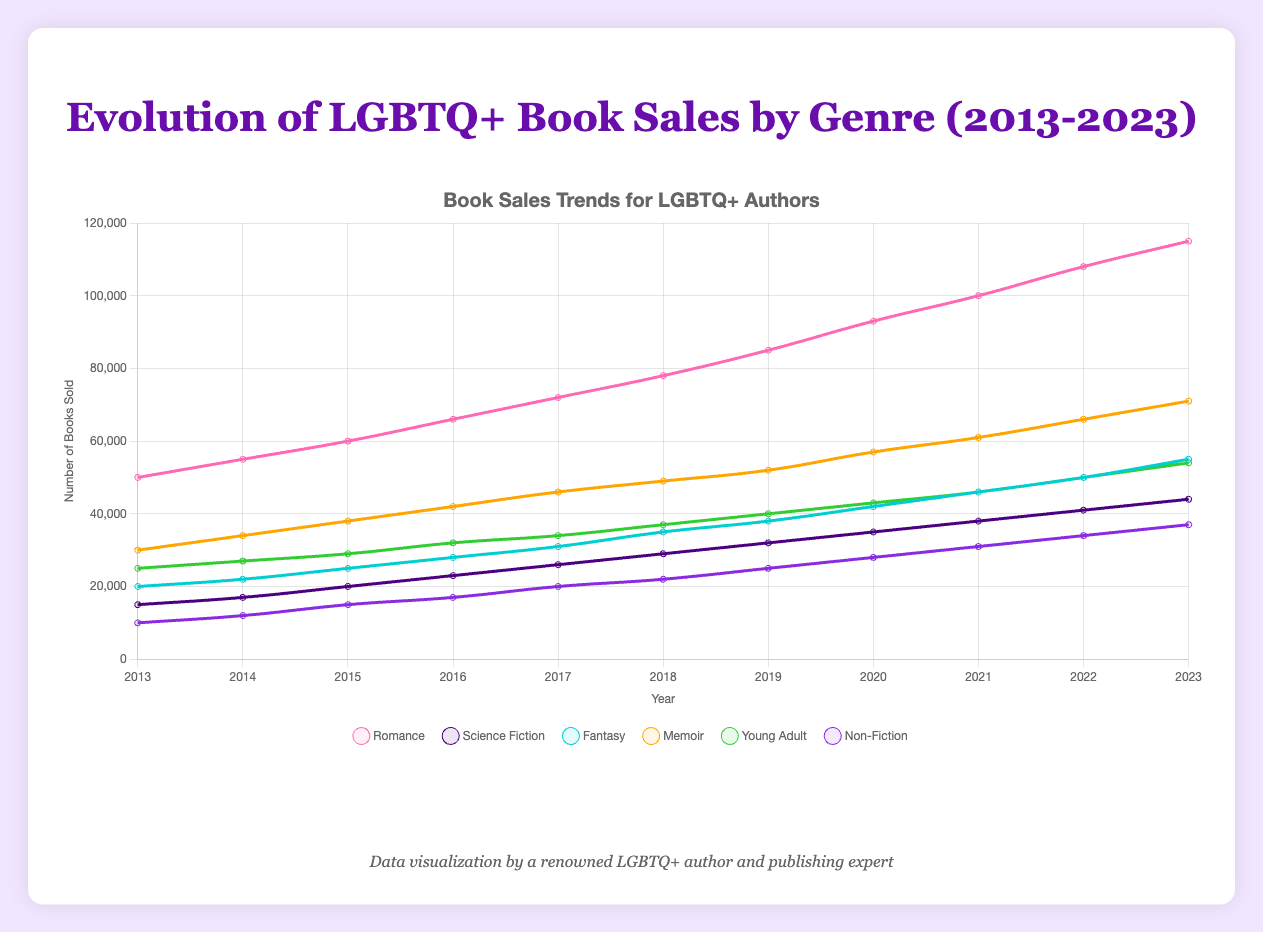How has the sales trend for Romance books changed over the last decade? Looking at the curve for Romance books, the sales have steadily increased from 50,000 in 2013 to 115,000 in 2023. The trend shows a consistent and significant upward movement.
Answer: Steady increase Which genre had the lowest sales in 2013, and how has it changed over time? In 2013, Non-Fiction had the lowest sales at 10,000. Over the decade, it has gradually increased each year, reaching 37,000 by 2023.
Answer: Non-Fiction, increased to 37,000 Which genre had the highest growth in book sales between 2013 and 2023? To determine the genre with the highest growth, compare the data points of each genre for 2013 and 2023. Romance had the highest increase, from 50,000 in 2013 to 115,000 in 2023, a growth of 65,000.
Answer: Romance Compare the sales of Fantasy and Young Adult books in 2023. Which one sold more, and by how much? Fantasy had 55,000 sales in 2023, while Young Adult had 54,000 sales. Fantasy sold 1,000 more books than Young Adult.
Answer: Fantasy, 1,000 more What is the average yearly sales increase for Memoir books from 2013 to 2023? Memoir sales in 2013 were 30,000, and in 2023 they were 71,000. The increase over 10 years is 71,000 - 30,000 = 41,000. The average yearly increase is 41,000 / 10 = 4,100 books per year.
Answer: 4,100 per year Between Science Fiction and Memoir, which genre had a more consistent growth, given the shape of the curves? The Memoir curve shows a steady and linear increase, while Science Fiction exhibits a more variable growth pattern. Therefore, Memoir had a more consistent growth.
Answer: Memoir How did the sales for Young Adult books change from 2017 to 2020? In 2017, Young Adult books had 34,000 sales, and in 2020 they had 43,000 sales. The increase over these three years is 43,000 - 34,000 = 9,000 books.
Answer: Increased by 9,000 What overall trend can you observe across all genres from 2013 to 2023? All genres show an upward trend in sales over the decade, indicating a general increase in the popularity of LGBTQ+ books across different genres.
Answer: Upward trend Which genre had the smallest change in sales from 2013 to 2023, and what was its change? Science Fiction had the smallest change in sales, increasing from 15,000 in 2013 to 44,000 in 2023, a total change of 29,000.
Answer: Science Fiction, 29,000 In which year did Fantasy book sales surpass the 50,000 mark? By inspecting the Fantasy book sales curve, we see that sales surpassed 50,000 in the year 2022.
Answer: 2022 